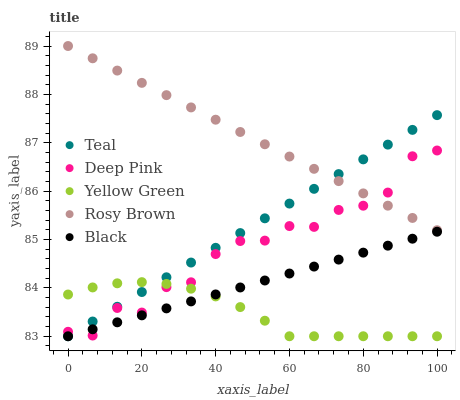Does Yellow Green have the minimum area under the curve?
Answer yes or no. Yes. Does Rosy Brown have the maximum area under the curve?
Answer yes or no. Yes. Does Deep Pink have the minimum area under the curve?
Answer yes or no. No. Does Deep Pink have the maximum area under the curve?
Answer yes or no. No. Is Black the smoothest?
Answer yes or no. Yes. Is Deep Pink the roughest?
Answer yes or no. Yes. Is Deep Pink the smoothest?
Answer yes or no. No. Is Black the roughest?
Answer yes or no. No. Does Black have the lowest value?
Answer yes or no. Yes. Does Deep Pink have the lowest value?
Answer yes or no. No. Does Rosy Brown have the highest value?
Answer yes or no. Yes. Does Deep Pink have the highest value?
Answer yes or no. No. Is Black less than Rosy Brown?
Answer yes or no. Yes. Is Rosy Brown greater than Yellow Green?
Answer yes or no. Yes. Does Teal intersect Yellow Green?
Answer yes or no. Yes. Is Teal less than Yellow Green?
Answer yes or no. No. Is Teal greater than Yellow Green?
Answer yes or no. No. Does Black intersect Rosy Brown?
Answer yes or no. No. 